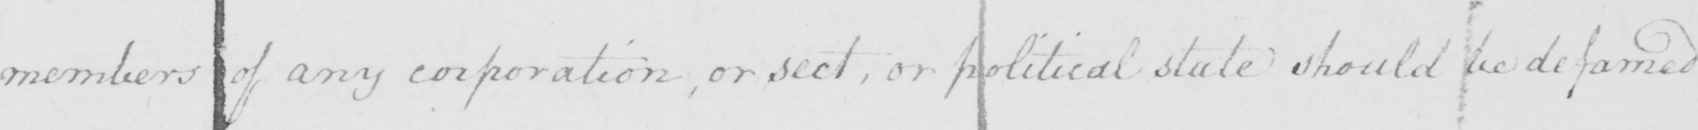Transcribe the text shown in this historical manuscript line. members of any corporation , or sect , or political state should be defamed 